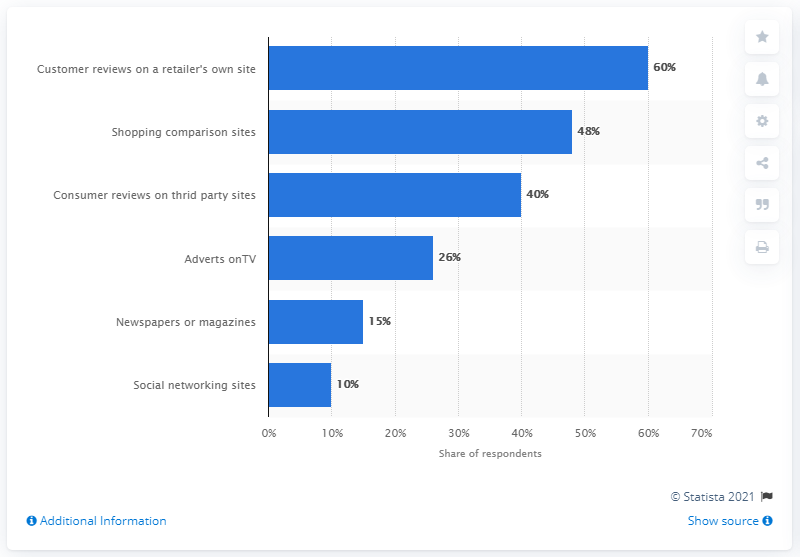Specify some key components in this picture. The average is 33.17. Social networking sites have the lowest volume of all sources. 